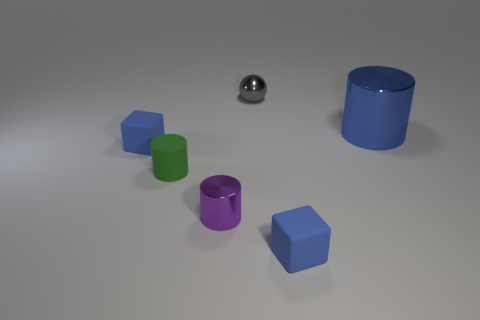Add 3 blue metallic cylinders. How many objects exist? 9 Subtract all spheres. How many objects are left? 5 Add 4 blue rubber things. How many blue rubber things are left? 6 Add 4 red rubber objects. How many red rubber objects exist? 4 Subtract 0 brown spheres. How many objects are left? 6 Subtract all green rubber objects. Subtract all metal things. How many objects are left? 2 